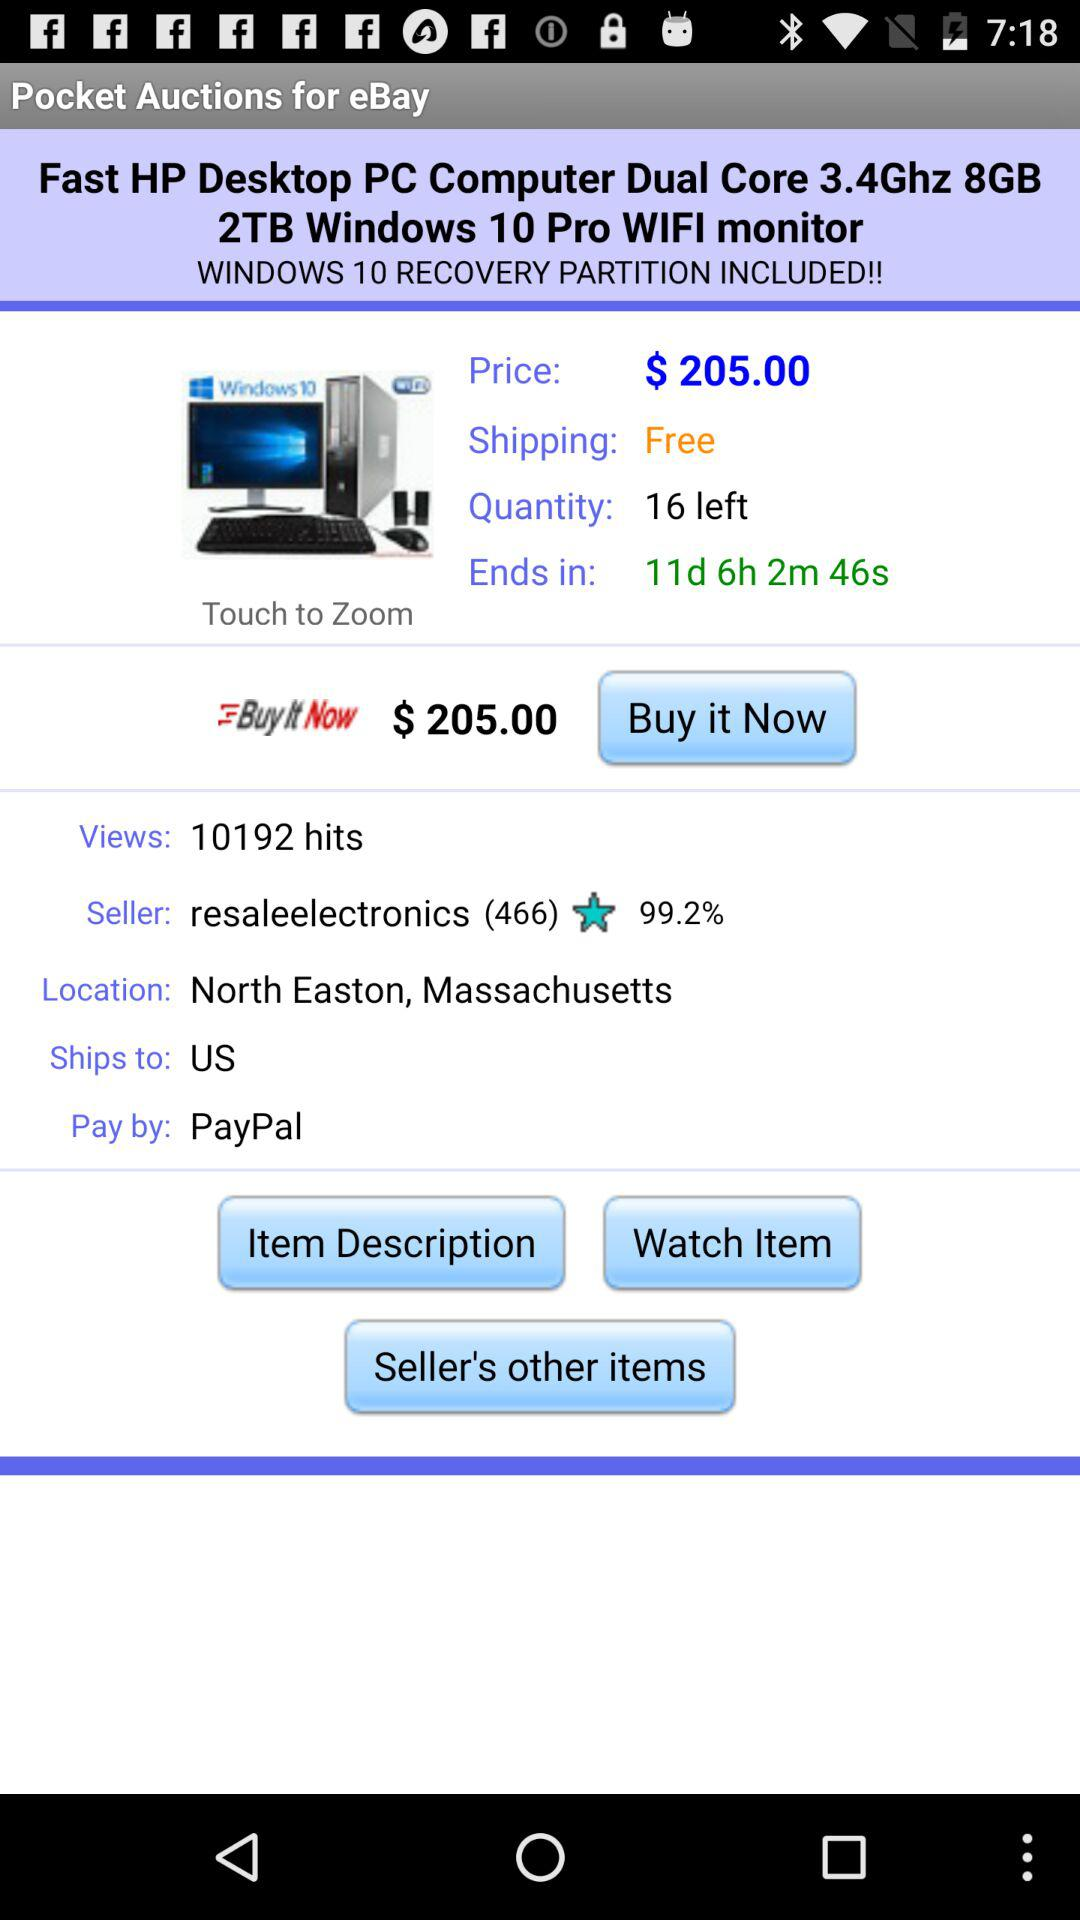What is the location? The location is North Easton, Massachusetts. 